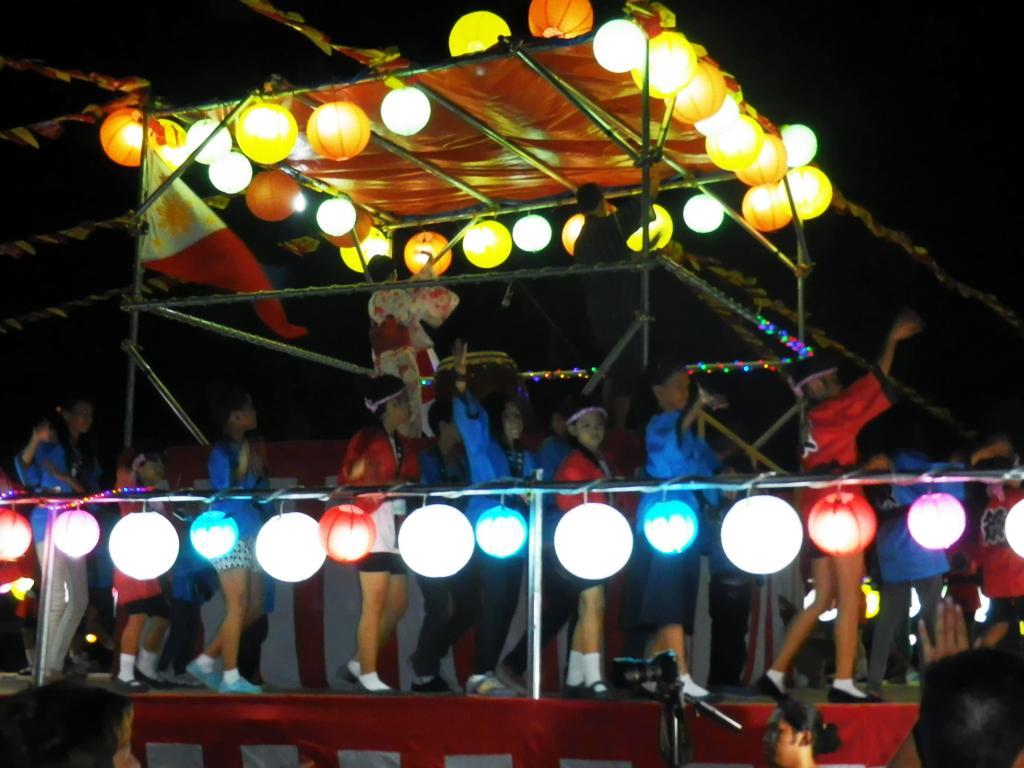Can you describe this image briefly? This picture seems to be clicked outside. In the center we can see the group of persons and we can see the paper lamps hanging on the metal rods, we can see the decoration lights and some other objects. 